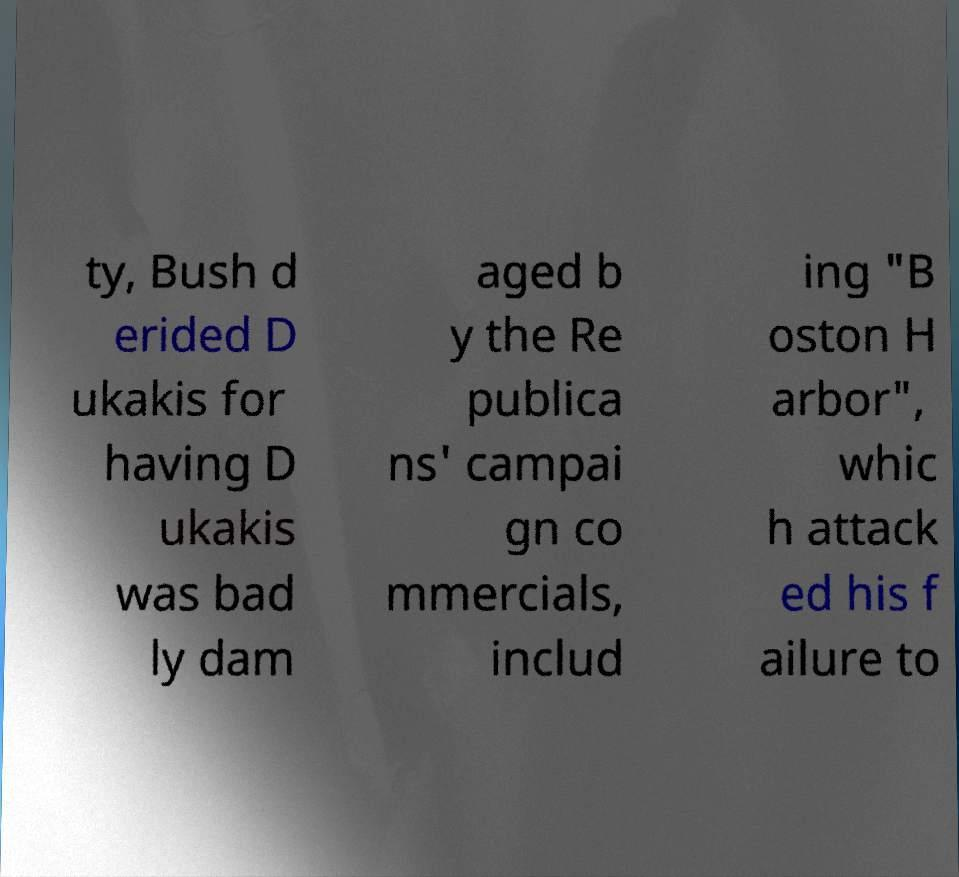Could you assist in decoding the text presented in this image and type it out clearly? ty, Bush d erided D ukakis for having D ukakis was bad ly dam aged b y the Re publica ns' campai gn co mmercials, includ ing "B oston H arbor", whic h attack ed his f ailure to 